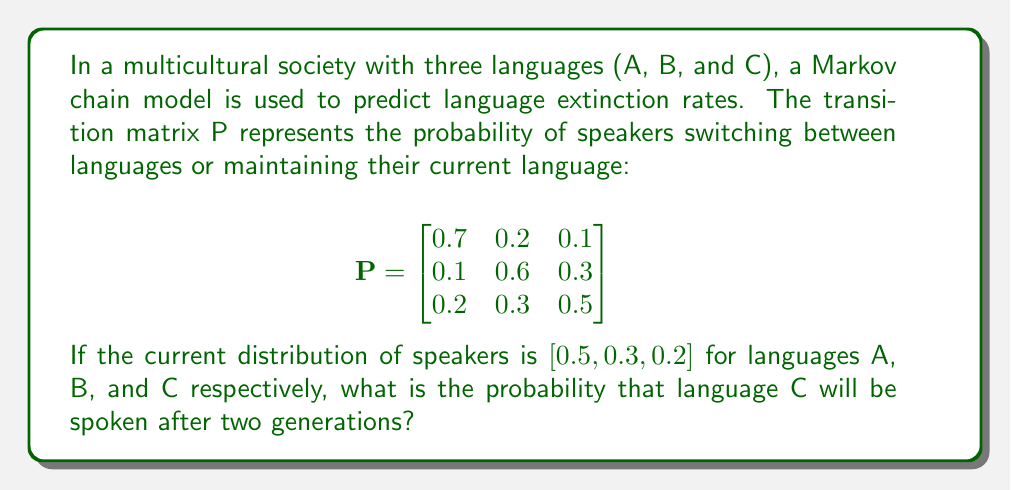Provide a solution to this math problem. To solve this problem, we'll use the Markov chain model and matrix multiplication:

1. Let $x_0 = [0.5, 0.3, 0.2]$ be the initial distribution vector.

2. To find the distribution after two generations, we need to multiply $x_0$ by $P$ twice:
   $x_2 = x_0 \cdot P^2$

3. First, calculate $P^2$:
   $$P^2 = P \cdot P = \begin{bmatrix}
   0.7 & 0.2 & 0.1 \\
   0.1 & 0.6 & 0.3 \\
   0.2 & 0.3 & 0.5
   \end{bmatrix} \cdot \begin{bmatrix}
   0.7 & 0.2 & 0.1 \\
   0.1 & 0.6 & 0.3 \\
   0.2 & 0.3 & 0.5
   \end{bmatrix}$$

   $$P^2 = \begin{bmatrix}
   0.53 & 0.27 & 0.20 \\
   0.22 & 0.45 & 0.33 \\
   0.27 & 0.36 & 0.37
   \end{bmatrix}$$

4. Now, multiply $x_0$ by $P^2$:
   $x_2 = [0.5, 0.3, 0.2] \cdot \begin{bmatrix}
   0.53 & 0.27 & 0.20 \\
   0.22 & 0.45 & 0.33 \\
   0.27 & 0.36 & 0.37
   \end{bmatrix}$

5. Perform the matrix multiplication:
   $x_2 = [0.395, 0.333, 0.272]$

6. The probability that language C will be spoken after two generations is the third component of $x_2$, which is 0.272 or 27.2%.

This result shows that despite starting with the smallest share, language C's usage increases slightly, demonstrating the dynamic nature of language evolution in a multicultural society.
Answer: 0.272 or 27.2% 